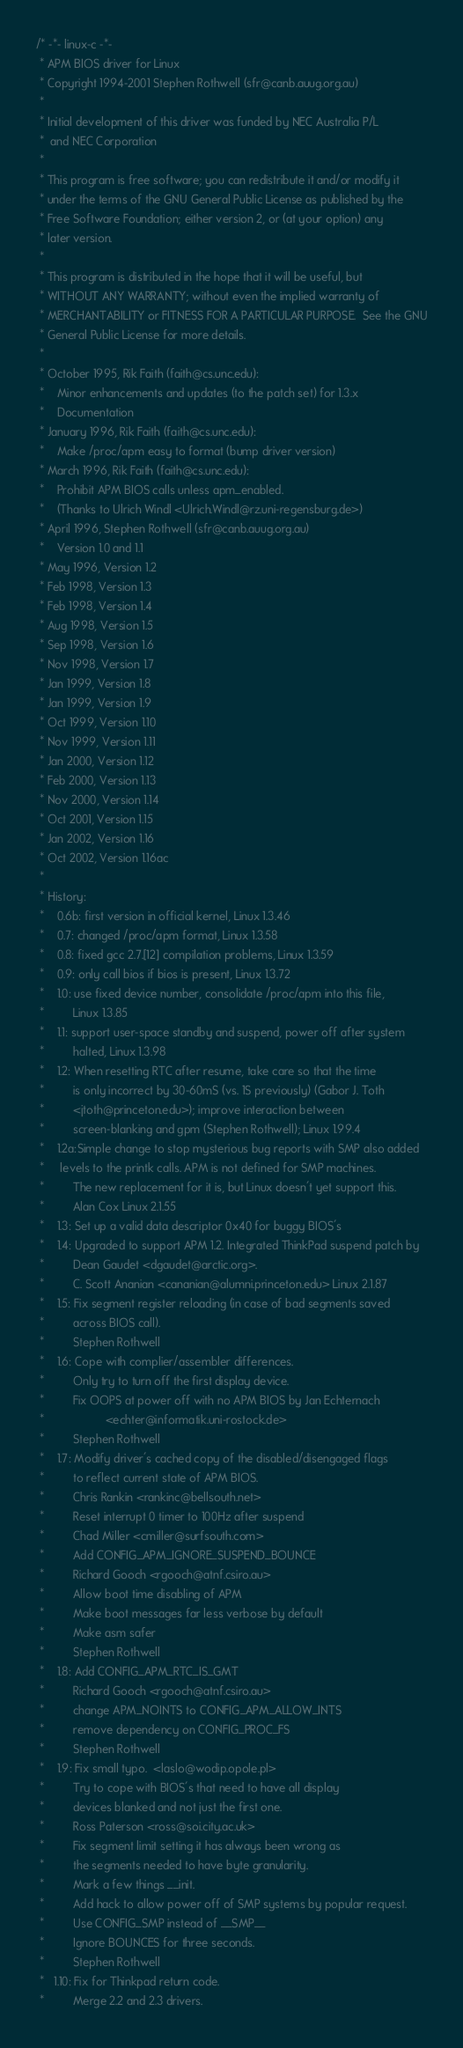<code> <loc_0><loc_0><loc_500><loc_500><_C_>/* -*- linux-c -*-
 * APM BIOS driver for Linux
 * Copyright 1994-2001 Stephen Rothwell (sfr@canb.auug.org.au)
 *
 * Initial development of this driver was funded by NEC Australia P/L
 *	and NEC Corporation
 *
 * This program is free software; you can redistribute it and/or modify it
 * under the terms of the GNU General Public License as published by the
 * Free Software Foundation; either version 2, or (at your option) any
 * later version.
 *
 * This program is distributed in the hope that it will be useful, but
 * WITHOUT ANY WARRANTY; without even the implied warranty of
 * MERCHANTABILITY or FITNESS FOR A PARTICULAR PURPOSE.  See the GNU
 * General Public License for more details.
 *
 * October 1995, Rik Faith (faith@cs.unc.edu):
 *    Minor enhancements and updates (to the patch set) for 1.3.x
 *    Documentation
 * January 1996, Rik Faith (faith@cs.unc.edu):
 *    Make /proc/apm easy to format (bump driver version)
 * March 1996, Rik Faith (faith@cs.unc.edu):
 *    Prohibit APM BIOS calls unless apm_enabled.
 *    (Thanks to Ulrich Windl <Ulrich.Windl@rz.uni-regensburg.de>)
 * April 1996, Stephen Rothwell (sfr@canb.auug.org.au)
 *    Version 1.0 and 1.1
 * May 1996, Version 1.2
 * Feb 1998, Version 1.3
 * Feb 1998, Version 1.4
 * Aug 1998, Version 1.5
 * Sep 1998, Version 1.6
 * Nov 1998, Version 1.7
 * Jan 1999, Version 1.8
 * Jan 1999, Version 1.9
 * Oct 1999, Version 1.10
 * Nov 1999, Version 1.11
 * Jan 2000, Version 1.12
 * Feb 2000, Version 1.13
 * Nov 2000, Version 1.14
 * Oct 2001, Version 1.15
 * Jan 2002, Version 1.16
 * Oct 2002, Version 1.16ac
 *
 * History:
 *    0.6b: first version in official kernel, Linux 1.3.46
 *    0.7: changed /proc/apm format, Linux 1.3.58
 *    0.8: fixed gcc 2.7.[12] compilation problems, Linux 1.3.59
 *    0.9: only call bios if bios is present, Linux 1.3.72
 *    1.0: use fixed device number, consolidate /proc/apm into this file,
 *         Linux 1.3.85
 *    1.1: support user-space standby and suspend, power off after system
 *         halted, Linux 1.3.98
 *    1.2: When resetting RTC after resume, take care so that the time
 *         is only incorrect by 30-60mS (vs. 1S previously) (Gabor J. Toth
 *         <jtoth@princeton.edu>); improve interaction between
 *         screen-blanking and gpm (Stephen Rothwell); Linux 1.99.4
 *    1.2a:Simple change to stop mysterious bug reports with SMP also added
 *	   levels to the printk calls. APM is not defined for SMP machines.
 *         The new replacement for it is, but Linux doesn't yet support this.
 *         Alan Cox Linux 2.1.55
 *    1.3: Set up a valid data descriptor 0x40 for buggy BIOS's
 *    1.4: Upgraded to support APM 1.2. Integrated ThinkPad suspend patch by
 *         Dean Gaudet <dgaudet@arctic.org>.
 *         C. Scott Ananian <cananian@alumni.princeton.edu> Linux 2.1.87
 *    1.5: Fix segment register reloading (in case of bad segments saved
 *         across BIOS call).
 *         Stephen Rothwell
 *    1.6: Cope with complier/assembler differences.
 *         Only try to turn off the first display device.
 *         Fix OOPS at power off with no APM BIOS by Jan Echternach
 *                   <echter@informatik.uni-rostock.de>
 *         Stephen Rothwell
 *    1.7: Modify driver's cached copy of the disabled/disengaged flags
 *         to reflect current state of APM BIOS.
 *         Chris Rankin <rankinc@bellsouth.net>
 *         Reset interrupt 0 timer to 100Hz after suspend
 *         Chad Miller <cmiller@surfsouth.com>
 *         Add CONFIG_APM_IGNORE_SUSPEND_BOUNCE
 *         Richard Gooch <rgooch@atnf.csiro.au>
 *         Allow boot time disabling of APM
 *         Make boot messages far less verbose by default
 *         Make asm safer
 *         Stephen Rothwell
 *    1.8: Add CONFIG_APM_RTC_IS_GMT
 *         Richard Gooch <rgooch@atnf.csiro.au>
 *         change APM_NOINTS to CONFIG_APM_ALLOW_INTS
 *         remove dependency on CONFIG_PROC_FS
 *         Stephen Rothwell
 *    1.9: Fix small typo.  <laslo@wodip.opole.pl>
 *         Try to cope with BIOS's that need to have all display
 *         devices blanked and not just the first one.
 *         Ross Paterson <ross@soi.city.ac.uk>
 *         Fix segment limit setting it has always been wrong as
 *         the segments needed to have byte granularity.
 *         Mark a few things __init.
 *         Add hack to allow power off of SMP systems by popular request.
 *         Use CONFIG_SMP instead of __SMP__
 *         Ignore BOUNCES for three seconds.
 *         Stephen Rothwell
 *   1.10: Fix for Thinkpad return code.
 *         Merge 2.2 and 2.3 drivers.</code> 